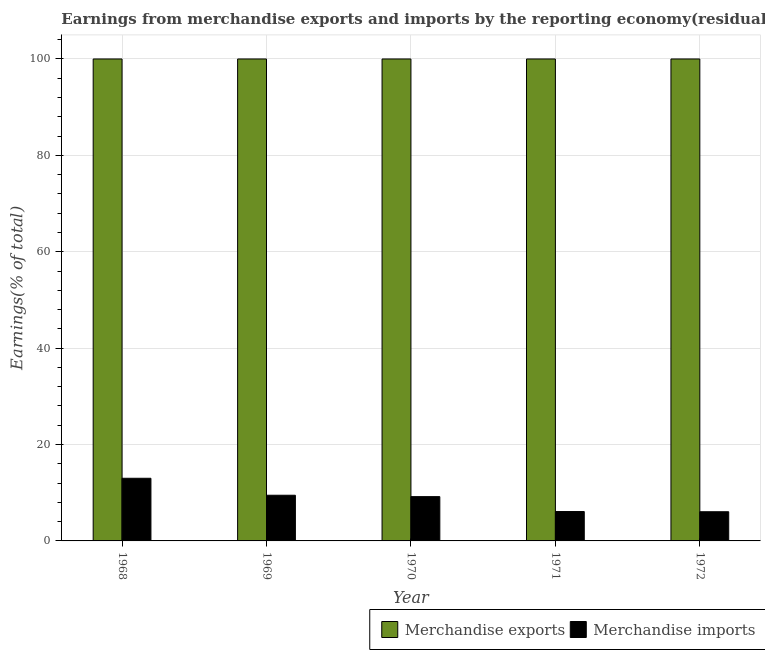Are the number of bars on each tick of the X-axis equal?
Keep it short and to the point. Yes. How many bars are there on the 3rd tick from the left?
Offer a terse response. 2. What is the label of the 2nd group of bars from the left?
Your answer should be compact. 1969. What is the earnings from merchandise imports in 1971?
Keep it short and to the point. 6.1. Across all years, what is the maximum earnings from merchandise imports?
Provide a short and direct response. 13. In which year was the earnings from merchandise exports maximum?
Offer a very short reply. 1968. In which year was the earnings from merchandise exports minimum?
Provide a succinct answer. 1968. What is the difference between the earnings from merchandise exports in 1968 and that in 1972?
Offer a terse response. 0. What is the difference between the earnings from merchandise exports in 1969 and the earnings from merchandise imports in 1972?
Your answer should be very brief. 0. What is the average earnings from merchandise imports per year?
Offer a terse response. 8.76. In the year 1968, what is the difference between the earnings from merchandise exports and earnings from merchandise imports?
Offer a very short reply. 0. In how many years, is the earnings from merchandise imports greater than 32 %?
Offer a very short reply. 0. What is the ratio of the earnings from merchandise imports in 1969 to that in 1972?
Keep it short and to the point. 1.57. Is the difference between the earnings from merchandise exports in 1969 and 1970 greater than the difference between the earnings from merchandise imports in 1969 and 1970?
Ensure brevity in your answer.  No. What is the difference between the highest and the lowest earnings from merchandise imports?
Offer a very short reply. 6.94. In how many years, is the earnings from merchandise imports greater than the average earnings from merchandise imports taken over all years?
Provide a short and direct response. 3. What does the 1st bar from the right in 1971 represents?
Offer a very short reply. Merchandise imports. How many bars are there?
Offer a terse response. 10. Are all the bars in the graph horizontal?
Ensure brevity in your answer.  No. Does the graph contain grids?
Offer a terse response. Yes. What is the title of the graph?
Your answer should be compact. Earnings from merchandise exports and imports by the reporting economy(residual) of Burkina Faso. What is the label or title of the X-axis?
Offer a very short reply. Year. What is the label or title of the Y-axis?
Keep it short and to the point. Earnings(% of total). What is the Earnings(% of total) in Merchandise imports in 1968?
Keep it short and to the point. 13. What is the Earnings(% of total) in Merchandise exports in 1969?
Keep it short and to the point. 100. What is the Earnings(% of total) in Merchandise imports in 1969?
Your answer should be very brief. 9.48. What is the Earnings(% of total) in Merchandise exports in 1970?
Ensure brevity in your answer.  100. What is the Earnings(% of total) in Merchandise imports in 1970?
Ensure brevity in your answer.  9.19. What is the Earnings(% of total) in Merchandise exports in 1971?
Offer a very short reply. 100. What is the Earnings(% of total) of Merchandise imports in 1971?
Ensure brevity in your answer.  6.1. What is the Earnings(% of total) in Merchandise imports in 1972?
Your answer should be very brief. 6.05. Across all years, what is the maximum Earnings(% of total) of Merchandise exports?
Keep it short and to the point. 100. Across all years, what is the maximum Earnings(% of total) in Merchandise imports?
Provide a short and direct response. 13. Across all years, what is the minimum Earnings(% of total) in Merchandise imports?
Offer a terse response. 6.05. What is the total Earnings(% of total) in Merchandise imports in the graph?
Make the answer very short. 43.81. What is the difference between the Earnings(% of total) of Merchandise imports in 1968 and that in 1969?
Offer a terse response. 3.52. What is the difference between the Earnings(% of total) in Merchandise exports in 1968 and that in 1970?
Your answer should be compact. 0. What is the difference between the Earnings(% of total) of Merchandise imports in 1968 and that in 1970?
Provide a succinct answer. 3.81. What is the difference between the Earnings(% of total) of Merchandise imports in 1968 and that in 1971?
Provide a short and direct response. 6.9. What is the difference between the Earnings(% of total) in Merchandise imports in 1968 and that in 1972?
Give a very brief answer. 6.94. What is the difference between the Earnings(% of total) of Merchandise imports in 1969 and that in 1970?
Your answer should be very brief. 0.29. What is the difference between the Earnings(% of total) of Merchandise imports in 1969 and that in 1971?
Provide a succinct answer. 3.38. What is the difference between the Earnings(% of total) in Merchandise imports in 1969 and that in 1972?
Your response must be concise. 3.42. What is the difference between the Earnings(% of total) in Merchandise imports in 1970 and that in 1971?
Offer a terse response. 3.09. What is the difference between the Earnings(% of total) in Merchandise exports in 1970 and that in 1972?
Keep it short and to the point. 0. What is the difference between the Earnings(% of total) in Merchandise imports in 1970 and that in 1972?
Give a very brief answer. 3.13. What is the difference between the Earnings(% of total) in Merchandise exports in 1971 and that in 1972?
Give a very brief answer. 0. What is the difference between the Earnings(% of total) of Merchandise imports in 1971 and that in 1972?
Your answer should be compact. 0.04. What is the difference between the Earnings(% of total) in Merchandise exports in 1968 and the Earnings(% of total) in Merchandise imports in 1969?
Make the answer very short. 90.52. What is the difference between the Earnings(% of total) of Merchandise exports in 1968 and the Earnings(% of total) of Merchandise imports in 1970?
Give a very brief answer. 90.81. What is the difference between the Earnings(% of total) in Merchandise exports in 1968 and the Earnings(% of total) in Merchandise imports in 1971?
Provide a short and direct response. 93.9. What is the difference between the Earnings(% of total) of Merchandise exports in 1968 and the Earnings(% of total) of Merchandise imports in 1972?
Offer a terse response. 93.95. What is the difference between the Earnings(% of total) in Merchandise exports in 1969 and the Earnings(% of total) in Merchandise imports in 1970?
Make the answer very short. 90.81. What is the difference between the Earnings(% of total) of Merchandise exports in 1969 and the Earnings(% of total) of Merchandise imports in 1971?
Give a very brief answer. 93.9. What is the difference between the Earnings(% of total) of Merchandise exports in 1969 and the Earnings(% of total) of Merchandise imports in 1972?
Ensure brevity in your answer.  93.95. What is the difference between the Earnings(% of total) of Merchandise exports in 1970 and the Earnings(% of total) of Merchandise imports in 1971?
Ensure brevity in your answer.  93.9. What is the difference between the Earnings(% of total) in Merchandise exports in 1970 and the Earnings(% of total) in Merchandise imports in 1972?
Your answer should be very brief. 93.95. What is the difference between the Earnings(% of total) in Merchandise exports in 1971 and the Earnings(% of total) in Merchandise imports in 1972?
Keep it short and to the point. 93.95. What is the average Earnings(% of total) in Merchandise imports per year?
Your answer should be compact. 8.76. In the year 1968, what is the difference between the Earnings(% of total) of Merchandise exports and Earnings(% of total) of Merchandise imports?
Offer a terse response. 87. In the year 1969, what is the difference between the Earnings(% of total) of Merchandise exports and Earnings(% of total) of Merchandise imports?
Offer a very short reply. 90.52. In the year 1970, what is the difference between the Earnings(% of total) in Merchandise exports and Earnings(% of total) in Merchandise imports?
Offer a very short reply. 90.81. In the year 1971, what is the difference between the Earnings(% of total) in Merchandise exports and Earnings(% of total) in Merchandise imports?
Your answer should be compact. 93.9. In the year 1972, what is the difference between the Earnings(% of total) in Merchandise exports and Earnings(% of total) in Merchandise imports?
Offer a very short reply. 93.95. What is the ratio of the Earnings(% of total) of Merchandise exports in 1968 to that in 1969?
Offer a very short reply. 1. What is the ratio of the Earnings(% of total) of Merchandise imports in 1968 to that in 1969?
Provide a succinct answer. 1.37. What is the ratio of the Earnings(% of total) in Merchandise imports in 1968 to that in 1970?
Your answer should be compact. 1.41. What is the ratio of the Earnings(% of total) in Merchandise imports in 1968 to that in 1971?
Provide a succinct answer. 2.13. What is the ratio of the Earnings(% of total) of Merchandise imports in 1968 to that in 1972?
Offer a very short reply. 2.15. What is the ratio of the Earnings(% of total) of Merchandise imports in 1969 to that in 1970?
Offer a terse response. 1.03. What is the ratio of the Earnings(% of total) of Merchandise imports in 1969 to that in 1971?
Ensure brevity in your answer.  1.55. What is the ratio of the Earnings(% of total) of Merchandise exports in 1969 to that in 1972?
Offer a terse response. 1. What is the ratio of the Earnings(% of total) in Merchandise imports in 1969 to that in 1972?
Give a very brief answer. 1.57. What is the ratio of the Earnings(% of total) in Merchandise imports in 1970 to that in 1971?
Your response must be concise. 1.51. What is the ratio of the Earnings(% of total) in Merchandise imports in 1970 to that in 1972?
Keep it short and to the point. 1.52. What is the ratio of the Earnings(% of total) of Merchandise exports in 1971 to that in 1972?
Ensure brevity in your answer.  1. What is the difference between the highest and the second highest Earnings(% of total) of Merchandise imports?
Offer a very short reply. 3.52. What is the difference between the highest and the lowest Earnings(% of total) of Merchandise exports?
Provide a short and direct response. 0. What is the difference between the highest and the lowest Earnings(% of total) in Merchandise imports?
Provide a succinct answer. 6.94. 